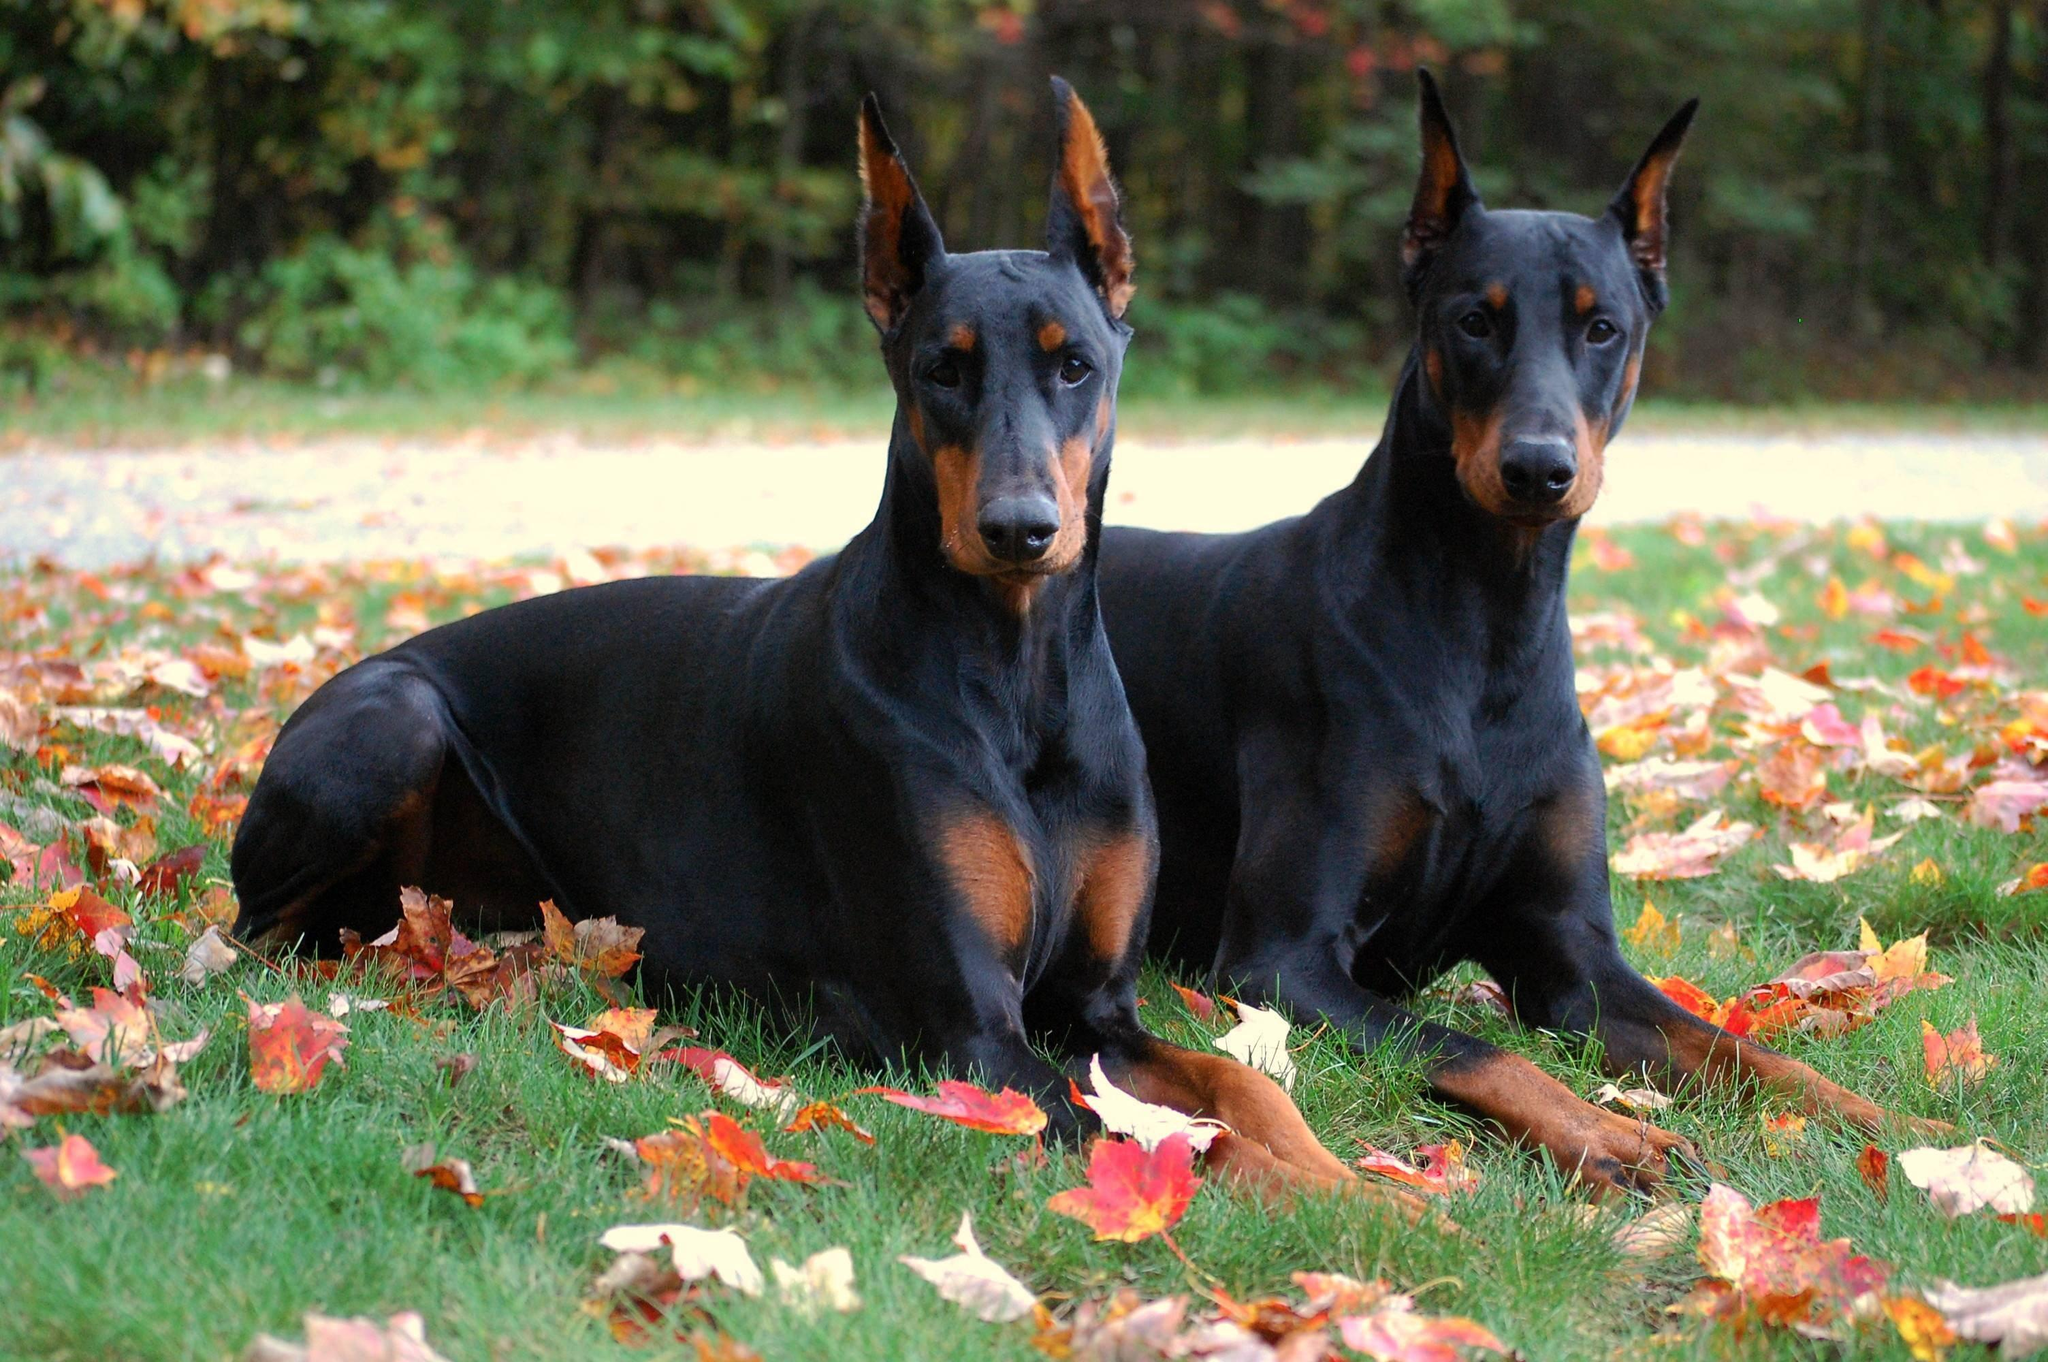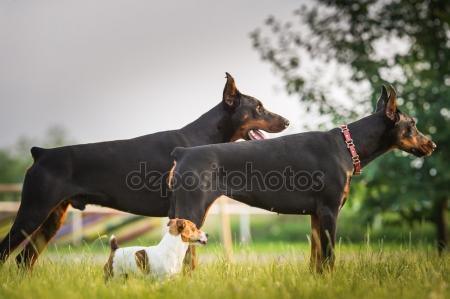The first image is the image on the left, the second image is the image on the right. For the images displayed, is the sentence "there are two dogs playing in the grass, one of the dogs has it's mouth open and looking back to the second dog" factually correct? Answer yes or no. No. The first image is the image on the left, the second image is the image on the right. Examine the images to the left and right. Is the description "The image on the right shows one dog sitting next to one dog standing." accurate? Answer yes or no. No. 